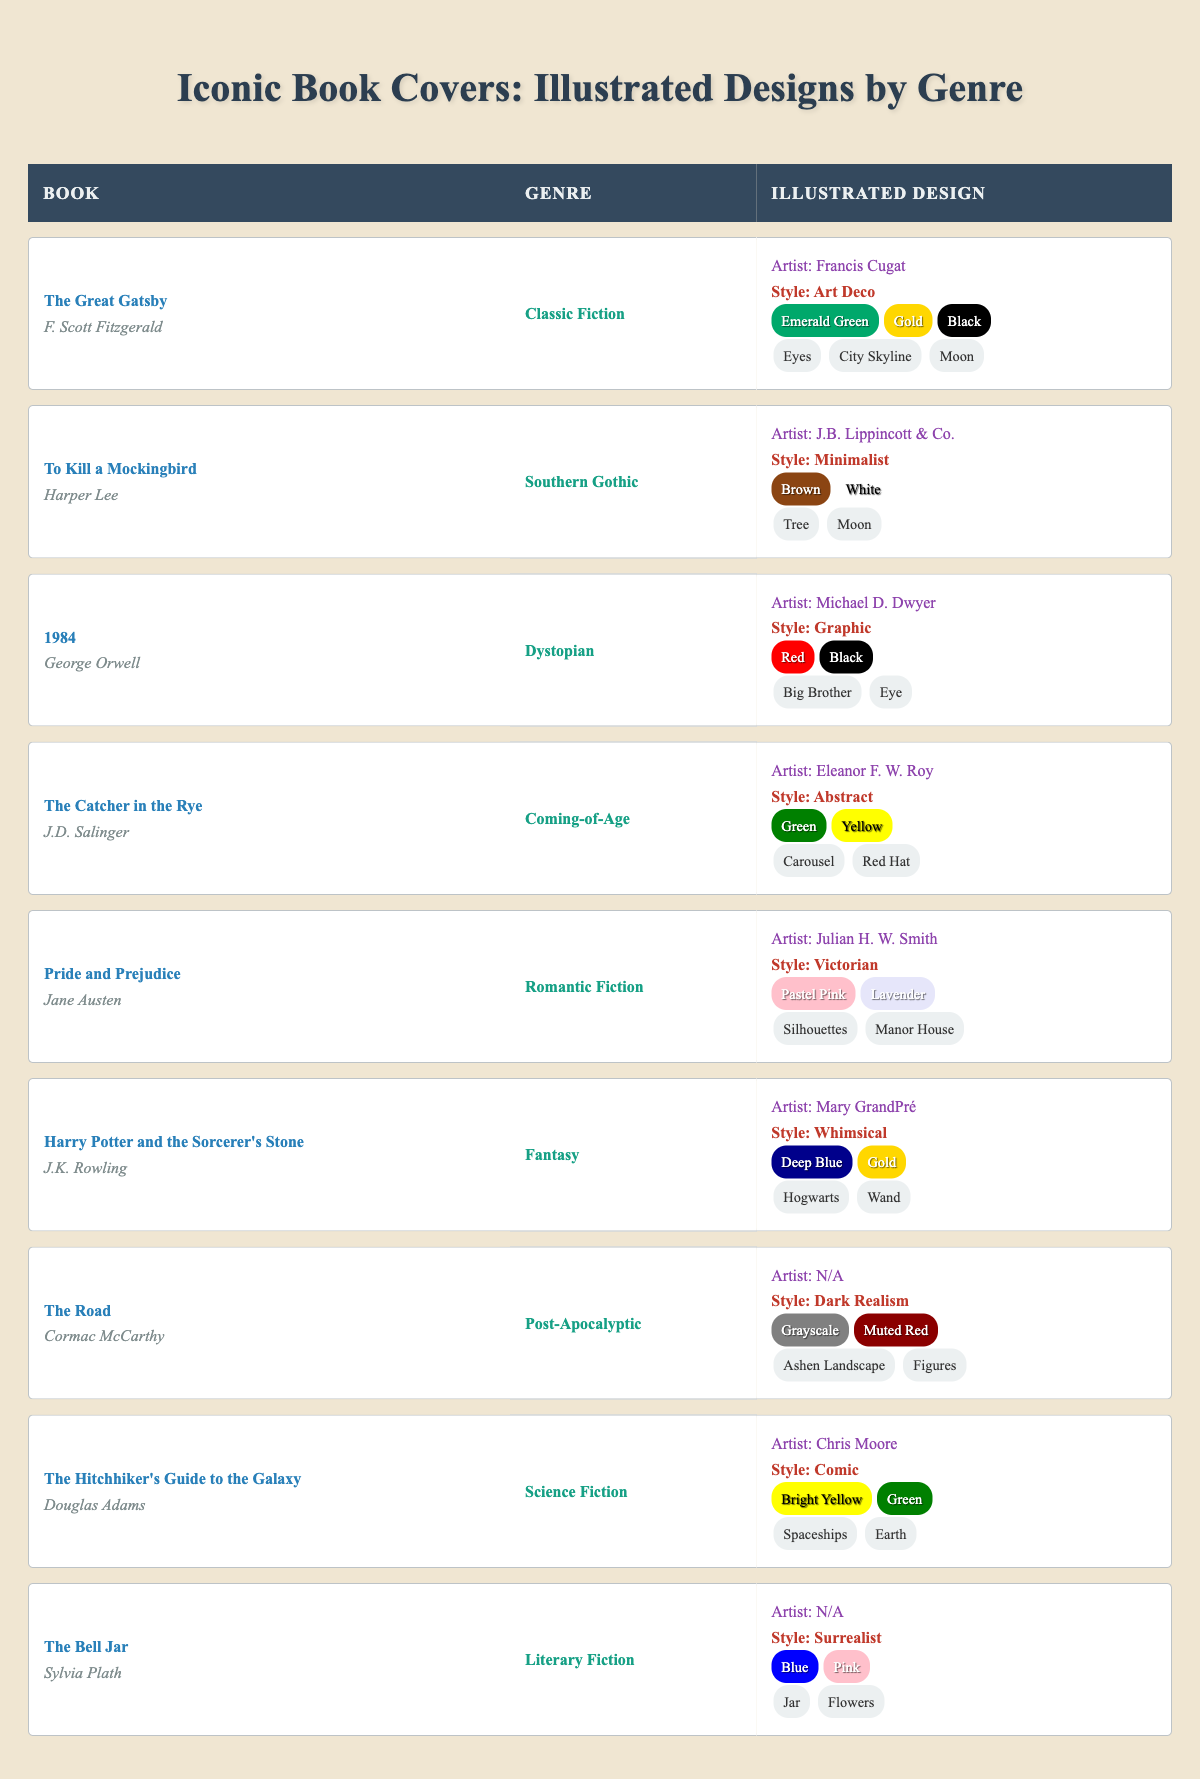What is the illustrated design style of "The Great Gatsby"? The table indicates that the illustrated design style of "The Great Gatsby" is Art Deco, as noted in the relevant row under the style column.
Answer: Art Deco Which book cover features a minimalist style? According to the table, "To Kill a Mockingbird" is the book that features a minimalist illustrated design style. This information can be found in the appropriate row under the style column.
Answer: To Kill a Mockingbird How many book covers in the table have been illustrated by artists noted as "N/A"? There are two entries (The Road and The Bell Jar) in the table where the artist is listed as N/A. This is determined by scanning the artist column for instances of N/A.
Answer: 2 Is there a book categorized under both Classic Fiction and illustrated in Art Deco style? Yes, "The Great Gatsby" is categorized under Classic Fiction and has an illustrated design style noted as Art Deco. This can be verified by reviewing the genre and style columns in the table.
Answer: Yes Which book covers utilize the color palette of Deep Blue and Gold? The table shows that "Harry Potter and the Sorcerer's Stone" is the only book cover that utilizes the color palette of Deep Blue and Gold, found under the color palette column.
Answer: Harry Potter and the Sorcerer's Stone How many genres in total are represented in the table? There are 9 distinct genres in the table, including Classic Fiction, Southern Gothic, Dystopian, Coming-of-Age, Romantic Fiction, Fantasy, Post-Apocalyptic, Science Fiction, and Literary Fiction. These can be counted by inspecting the genre column.
Answer: 9 Which illustrated design style is shared by both "The Hitchhiker's Guide to the Galaxy" and "The Catcher in the Rye"? The table reveals that neither "The Hitchhiker's Guide to the Galaxy" nor "The Catcher in the Rye" share the same illustrated design style. The former has a Comic style, while the latter has an Abstract style, so they are distinctly different.
Answer: No What is the average number of primary colors displayed in the color palettes of the books? To find the average, we first list the number of colors in each book's palette. Most color palettes have 2 or 3 colors. Counting each, we find a total of 22 colors across 10 books, leading to an average of 2.2. Thus, we calculate the total (22) divided by the number of entries (10) equals 2.2.
Answer: 2.2 